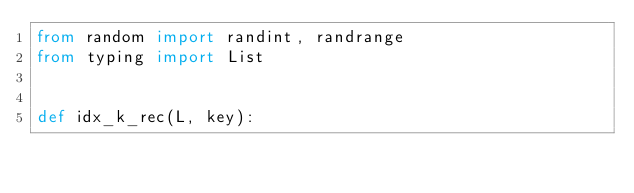Convert code to text. <code><loc_0><loc_0><loc_500><loc_500><_Python_>from random import randint, randrange
from typing import List


def idx_k_rec(L, key):</code> 